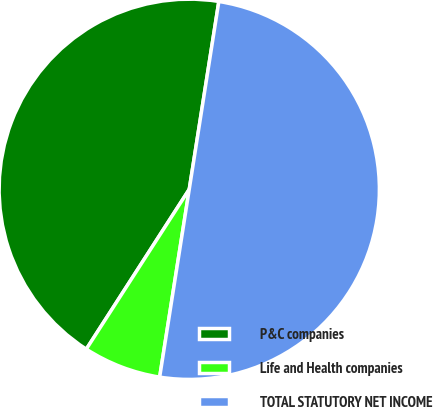Convert chart. <chart><loc_0><loc_0><loc_500><loc_500><pie_chart><fcel>P&C companies<fcel>Life and Health companies<fcel>TOTAL STATUTORY NET INCOME<nl><fcel>43.38%<fcel>6.62%<fcel>50.0%<nl></chart> 